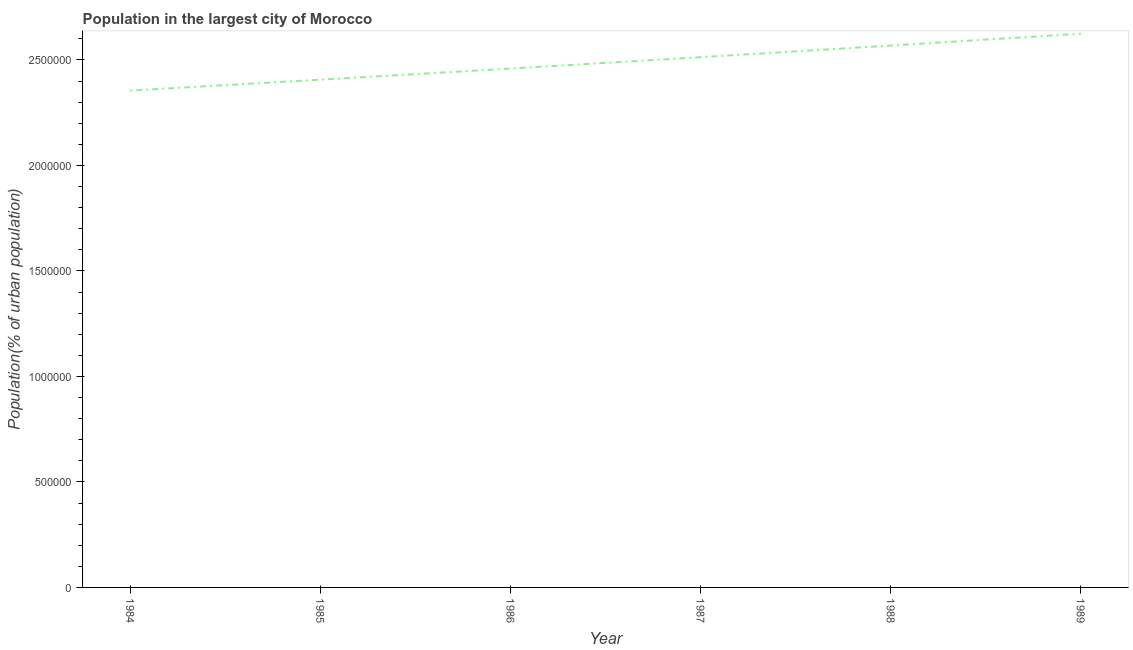What is the population in largest city in 1987?
Provide a short and direct response. 2.51e+06. Across all years, what is the maximum population in largest city?
Keep it short and to the point. 2.62e+06. Across all years, what is the minimum population in largest city?
Offer a very short reply. 2.35e+06. In which year was the population in largest city maximum?
Provide a succinct answer. 1989. What is the sum of the population in largest city?
Keep it short and to the point. 1.49e+07. What is the difference between the population in largest city in 1987 and 1989?
Offer a very short reply. -1.11e+05. What is the average population in largest city per year?
Your answer should be very brief. 2.49e+06. What is the median population in largest city?
Your answer should be very brief. 2.49e+06. In how many years, is the population in largest city greater than 300000 %?
Your response must be concise. 6. Do a majority of the years between 1986 and 1985 (inclusive) have population in largest city greater than 1400000 %?
Provide a short and direct response. No. What is the ratio of the population in largest city in 1987 to that in 1989?
Give a very brief answer. 0.96. What is the difference between the highest and the second highest population in largest city?
Ensure brevity in your answer.  5.62e+04. Is the sum of the population in largest city in 1986 and 1988 greater than the maximum population in largest city across all years?
Give a very brief answer. Yes. What is the difference between the highest and the lowest population in largest city?
Your answer should be compact. 2.70e+05. In how many years, is the population in largest city greater than the average population in largest city taken over all years?
Keep it short and to the point. 3. What is the title of the graph?
Offer a terse response. Population in the largest city of Morocco. What is the label or title of the Y-axis?
Provide a short and direct response. Population(% of urban population). What is the Population(% of urban population) of 1984?
Offer a terse response. 2.35e+06. What is the Population(% of urban population) of 1985?
Your answer should be very brief. 2.41e+06. What is the Population(% of urban population) of 1986?
Keep it short and to the point. 2.46e+06. What is the Population(% of urban population) in 1987?
Your response must be concise. 2.51e+06. What is the Population(% of urban population) in 1988?
Provide a short and direct response. 2.57e+06. What is the Population(% of urban population) in 1989?
Your answer should be compact. 2.62e+06. What is the difference between the Population(% of urban population) in 1984 and 1985?
Give a very brief answer. -5.15e+04. What is the difference between the Population(% of urban population) in 1984 and 1986?
Give a very brief answer. -1.04e+05. What is the difference between the Population(% of urban population) in 1984 and 1987?
Your answer should be very brief. -1.58e+05. What is the difference between the Population(% of urban population) in 1984 and 1988?
Keep it short and to the point. -2.13e+05. What is the difference between the Population(% of urban population) in 1984 and 1989?
Your answer should be compact. -2.70e+05. What is the difference between the Population(% of urban population) in 1985 and 1986?
Your answer should be very brief. -5.28e+04. What is the difference between the Population(% of urban population) in 1985 and 1987?
Offer a terse response. -1.07e+05. What is the difference between the Population(% of urban population) in 1985 and 1988?
Provide a short and direct response. -1.62e+05. What is the difference between the Population(% of urban population) in 1985 and 1989?
Offer a very short reply. -2.18e+05. What is the difference between the Population(% of urban population) in 1986 and 1987?
Offer a terse response. -5.39e+04. What is the difference between the Population(% of urban population) in 1986 and 1988?
Give a very brief answer. -1.09e+05. What is the difference between the Population(% of urban population) in 1986 and 1989?
Make the answer very short. -1.65e+05. What is the difference between the Population(% of urban population) in 1987 and 1988?
Give a very brief answer. -5.52e+04. What is the difference between the Population(% of urban population) in 1987 and 1989?
Give a very brief answer. -1.11e+05. What is the difference between the Population(% of urban population) in 1988 and 1989?
Ensure brevity in your answer.  -5.62e+04. What is the ratio of the Population(% of urban population) in 1984 to that in 1986?
Your response must be concise. 0.96. What is the ratio of the Population(% of urban population) in 1984 to that in 1987?
Make the answer very short. 0.94. What is the ratio of the Population(% of urban population) in 1984 to that in 1988?
Offer a terse response. 0.92. What is the ratio of the Population(% of urban population) in 1984 to that in 1989?
Make the answer very short. 0.9. What is the ratio of the Population(% of urban population) in 1985 to that in 1986?
Your answer should be compact. 0.98. What is the ratio of the Population(% of urban population) in 1985 to that in 1987?
Provide a short and direct response. 0.96. What is the ratio of the Population(% of urban population) in 1985 to that in 1988?
Your answer should be very brief. 0.94. What is the ratio of the Population(% of urban population) in 1985 to that in 1989?
Your answer should be compact. 0.92. What is the ratio of the Population(% of urban population) in 1986 to that in 1988?
Offer a terse response. 0.96. What is the ratio of the Population(% of urban population) in 1986 to that in 1989?
Provide a short and direct response. 0.94. What is the ratio of the Population(% of urban population) in 1987 to that in 1988?
Your response must be concise. 0.98. What is the ratio of the Population(% of urban population) in 1987 to that in 1989?
Keep it short and to the point. 0.96. 